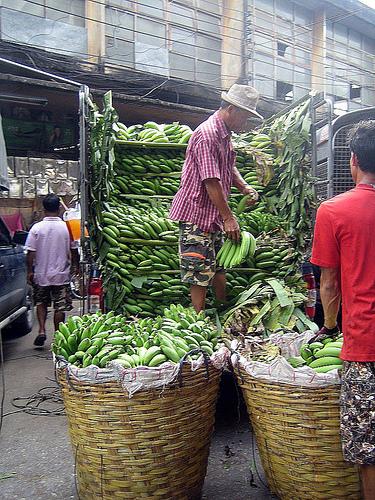How many baskets are in the photo?
Write a very short answer. 2. Are the fruit ripe?
Write a very short answer. No. What type of fruit are being sold?
Be succinct. Bananas. 